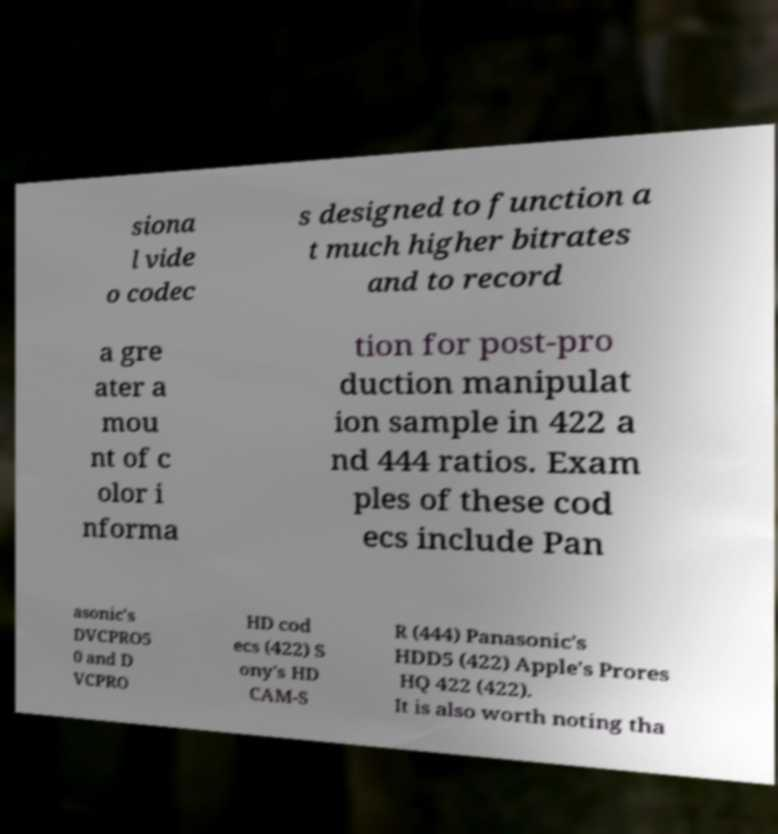Could you extract and type out the text from this image? siona l vide o codec s designed to function a t much higher bitrates and to record a gre ater a mou nt of c olor i nforma tion for post-pro duction manipulat ion sample in 422 a nd 444 ratios. Exam ples of these cod ecs include Pan asonic's DVCPRO5 0 and D VCPRO HD cod ecs (422) S ony's HD CAM-S R (444) Panasonic's HDD5 (422) Apple's Prores HQ 422 (422). It is also worth noting tha 